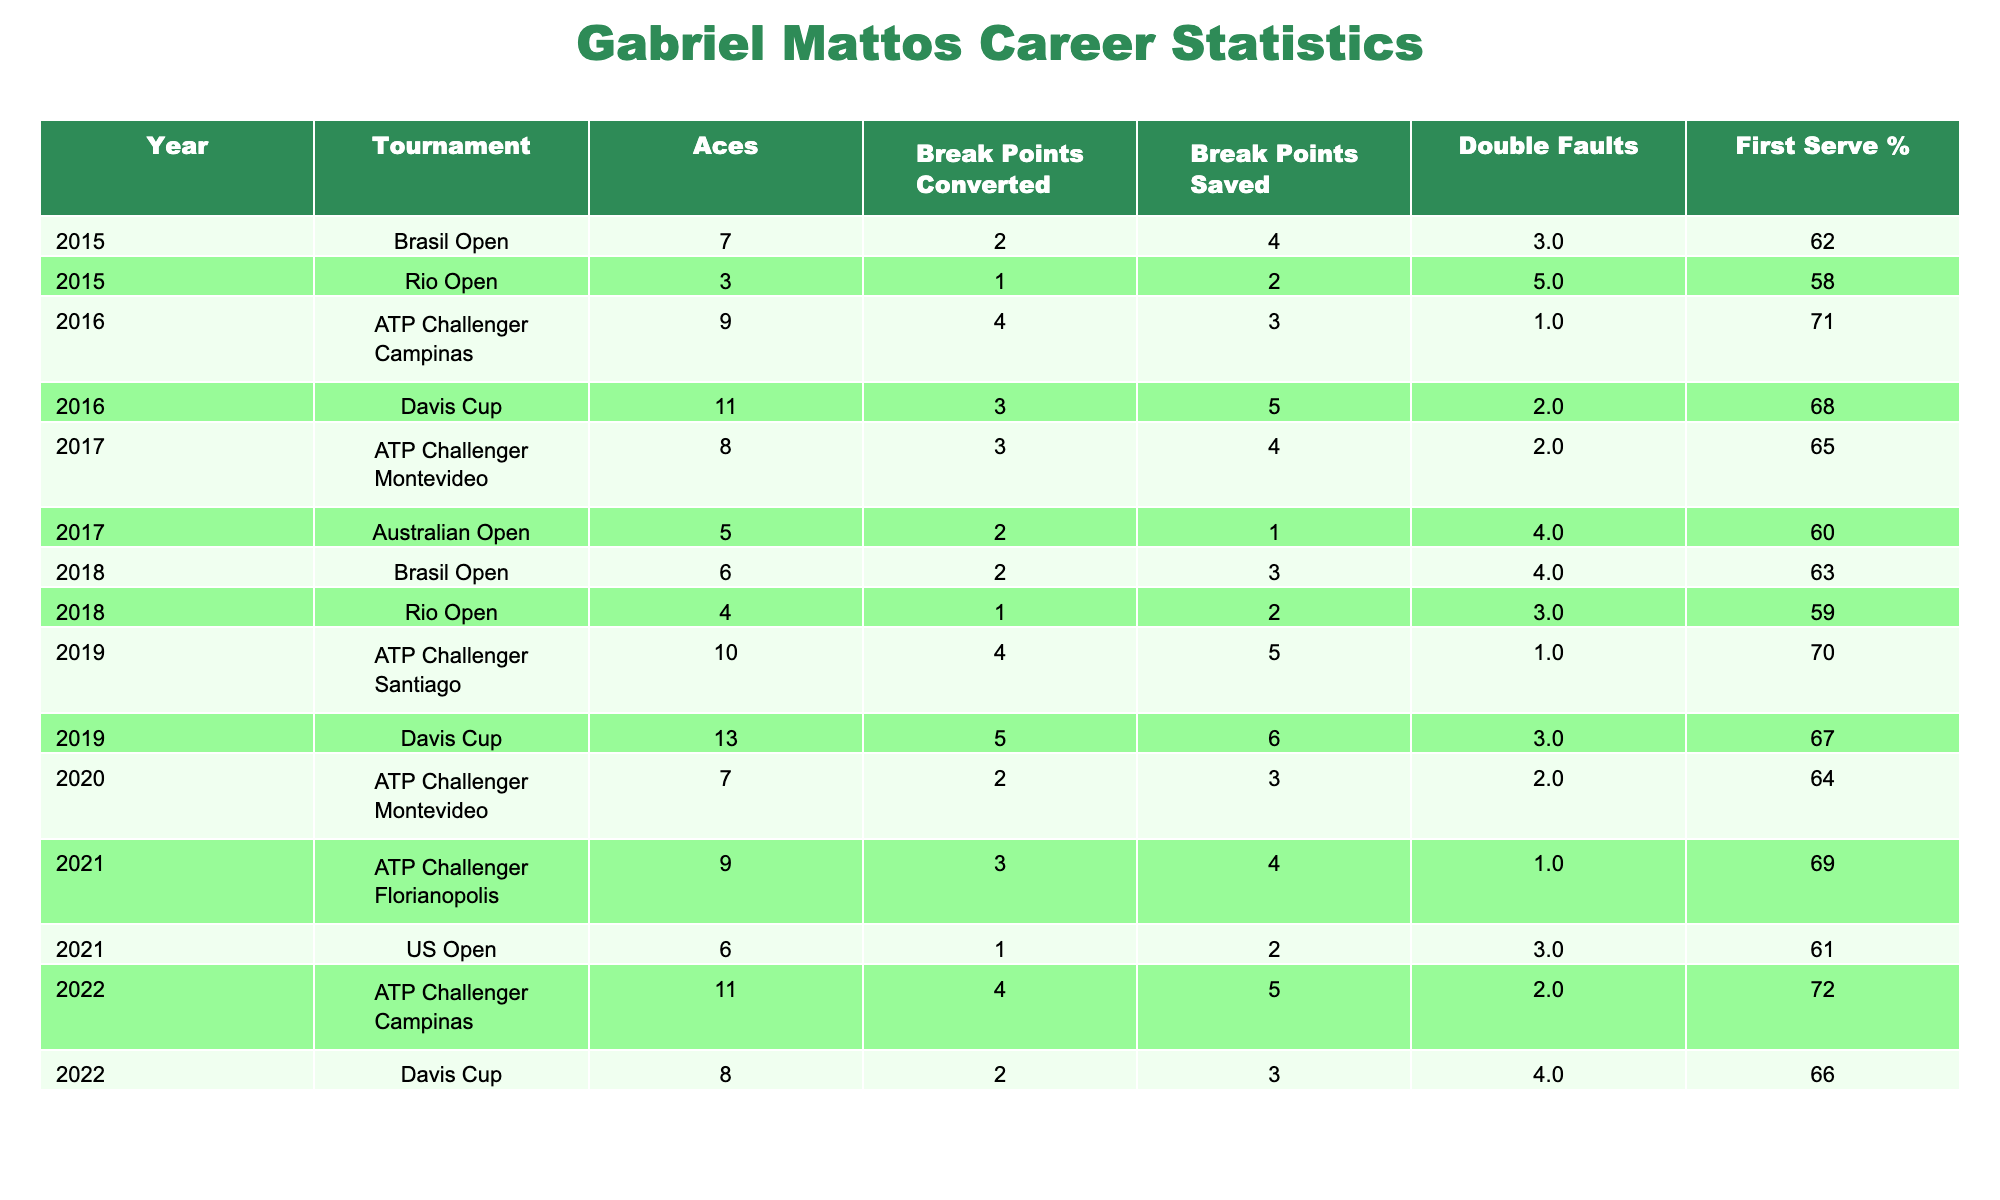What is the total number of aces recorded by Gabriel Mattos in 2019? In 2019, there are two tournaments listed for Gabriel Mattos: the ATP Challenger Santiago and the Davis Cup. In the ATP Challenger Santiago, he recorded 10 aces, and in the Davis Cup, he recorded 13 aces. Thus, the total number of aces is 10 + 13 = 23.
Answer: 23 What was Gabriel Mattos' best first serve percentage in a single tournament? To find the best first serve percentage, we examine the "First Serve %" column across all tournaments. The highest value in this column is 72%, which occurred in the ATP Challenger Campinas in 2022.
Answer: 72 Did Gabriel Mattos win any tournaments in the year 2016? In 2016, he played two tournaments: the Davis Cup and the ATP Challenger Campinas. He won in the Davis Cup against Federico Delbonis but lost in the ATP Challenger Campinas. Thus, the answer is yes.
Answer: Yes How many different tournaments did Gabriel Mattos participate in throughout his career as noted in the data? He played in a total of six distinct tournaments: the Rio Open, Brasil Open, Davis Cup, ATP Challenger Campinas, ATP Challenger Montevideo, and ATP Challenger Florianopolis. Thus, the answer is six.
Answer: 6 What is the average number of double faults made by Gabriel Mattos during tournaments he lost? We need to consider only the tournaments where he lost. The double faults in these tournaments are: 5 (Rio Open) + 3 (Brasil Open) + 4 (Australian Open) + 3 (Rio Open) + 4 (Brasil Open) + 2 (ATP Challenger Montevideo) + 3 (US Open) + 4 (Davis Cup). Adding these gives a total of 32 double faults over 8 losses, resulting in an average of 32/8 = 4.
Answer: 4 In how many matches did Gabriel successfully save more break points than he converted in 2022? In 2022, he played in two matches: the ATP Challenger Campinas and the Davis Cup. In the ATP Challenger, he saved 5 break points and converted 4, and in the Davis Cup, he saved 3 break points but converted 2. In both matches (5 > 4 and 3 > 2), he saved more break points than he converted. Thus, the total is 2 matches.
Answer: 2 How many sets did Gabriel Mattos lose in total throughout his career according to the data provided? To find the total sets lost, we sum the "Sets Lost" column across all tournaments. The sets lost are: 2 + 2 + 1 + 0 + 2 + 1 + 2 + 2 + 1 + 2 + 3 = 20 sets lost in total.
Answer: 20 What was the outcome of Gabriel Mattos' match against Marco Cecchinato in the 2017 ATP Challenger Montevideo? According to the data, in 2017 at the ATP Challenger Montevideo, Gabriel Mattos played against Marco Cecchinato and won the match (result: Win).
Answer: Win What was Gabriel Mattos' performance trend regarding break points in 2021 compared to 2022? In 2021, he converted 3 break points in two matches (ATP Challenger Florianopolis and US Open), saving 4 in the first match and 2 in the second. In 2022, he converted 4 break points in the ATP Challenger and 2 in Davis Cup while saving 5 and 3 respectively. Thus, he was more successful in both saving and converting break points in 2022 compared to 2021.
Answer: Improved 